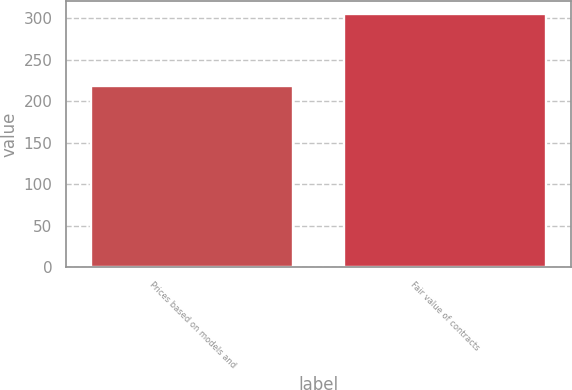Convert chart. <chart><loc_0><loc_0><loc_500><loc_500><bar_chart><fcel>Prices based on models and<fcel>Fair value of contracts<nl><fcel>218<fcel>305<nl></chart> 